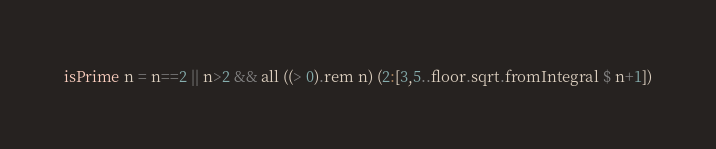<code> <loc_0><loc_0><loc_500><loc_500><_Haskell_>isPrime n = n==2 || n>2 && all ((> 0).rem n) (2:[3,5..floor.sqrt.fromIntegral $ n+1])
</code> 